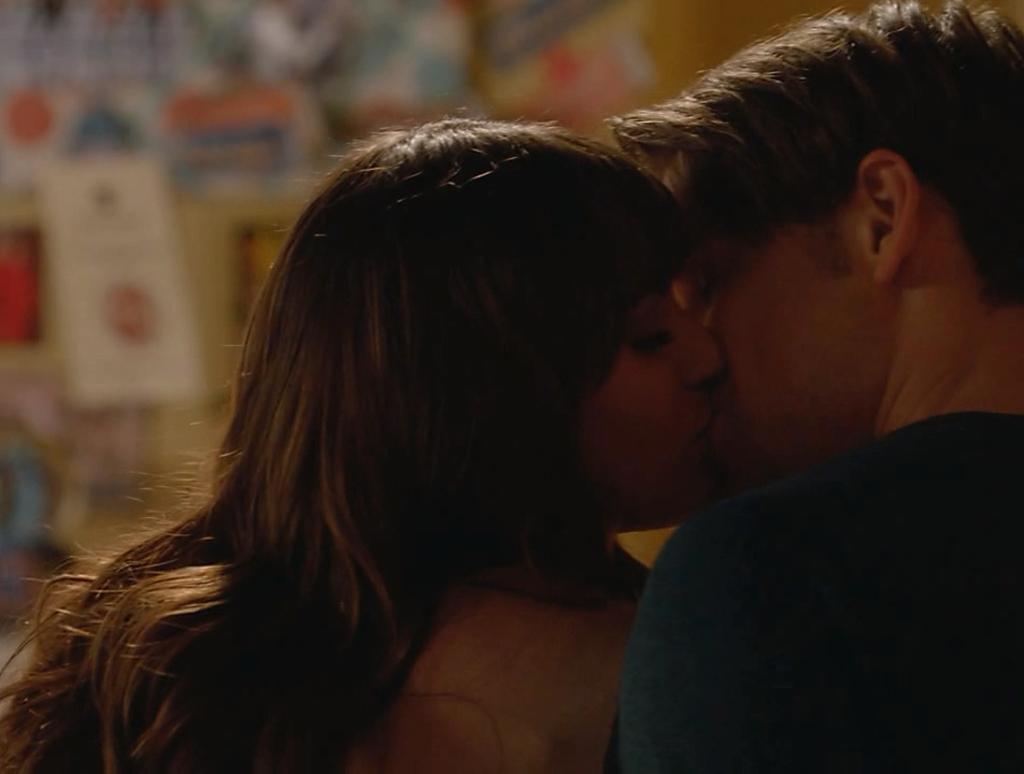Please provide a concise description of this image. In this image there are two persons kissing, the background of the image is blurred. 